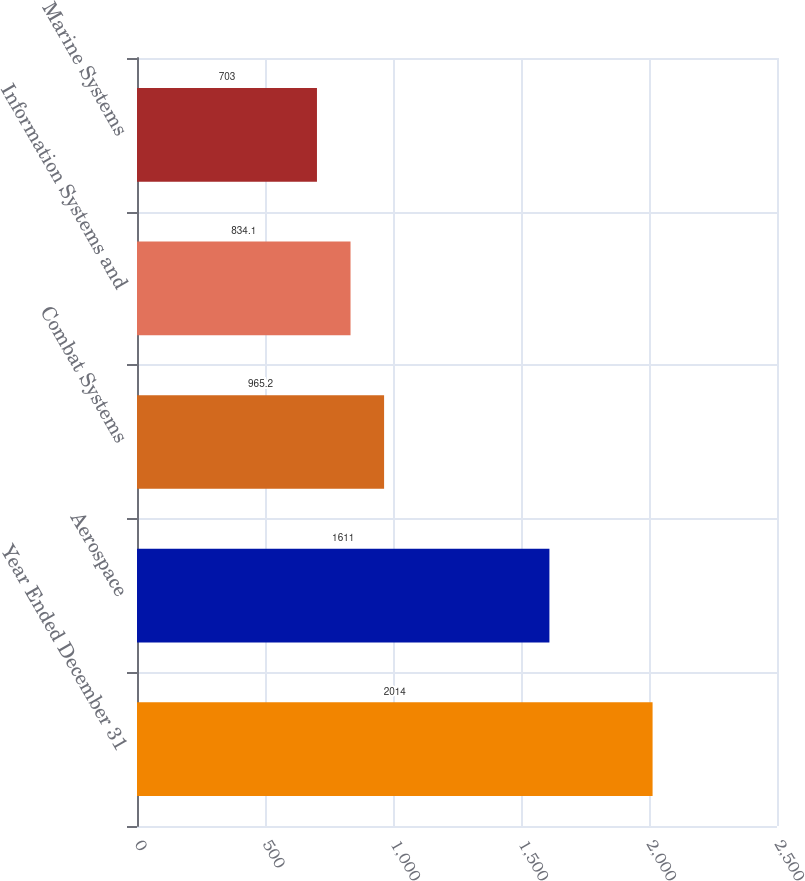Convert chart to OTSL. <chart><loc_0><loc_0><loc_500><loc_500><bar_chart><fcel>Year Ended December 31<fcel>Aerospace<fcel>Combat Systems<fcel>Information Systems and<fcel>Marine Systems<nl><fcel>2014<fcel>1611<fcel>965.2<fcel>834.1<fcel>703<nl></chart> 